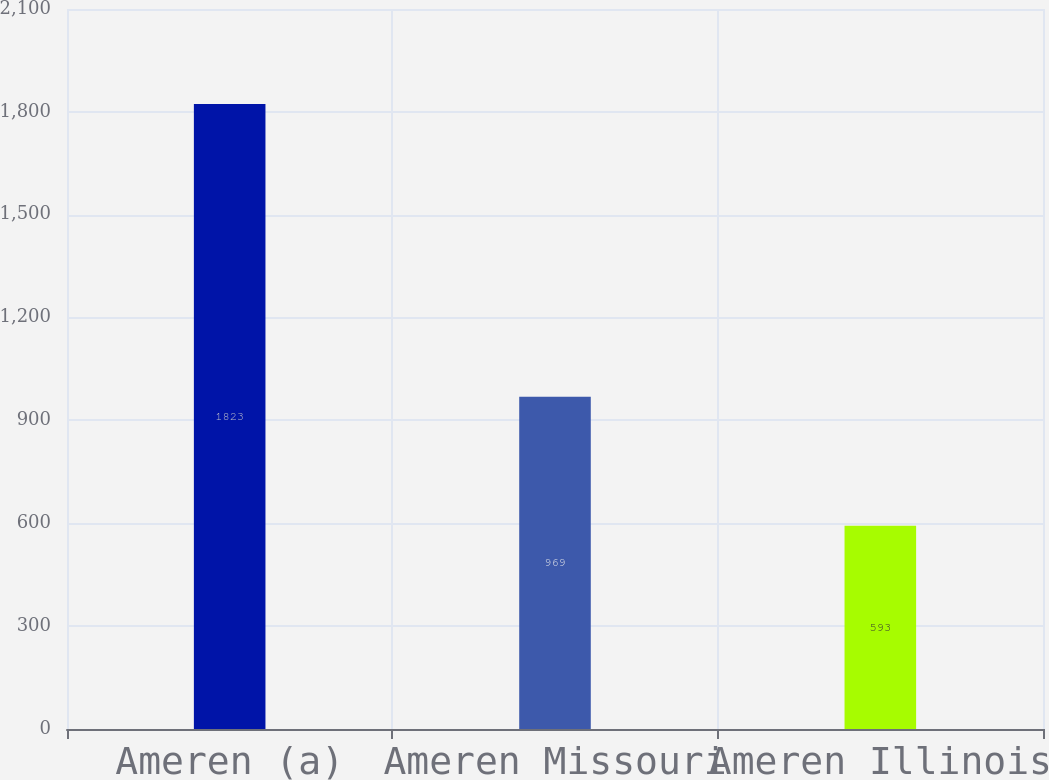Convert chart. <chart><loc_0><loc_0><loc_500><loc_500><bar_chart><fcel>Ameren (a)<fcel>Ameren Missouri<fcel>Ameren Illinois<nl><fcel>1823<fcel>969<fcel>593<nl></chart> 